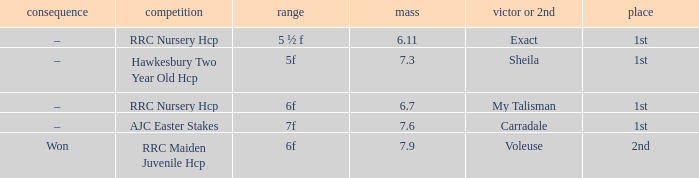What was the race when the winner of 2nd was Voleuse? RRC Maiden Juvenile Hcp. 